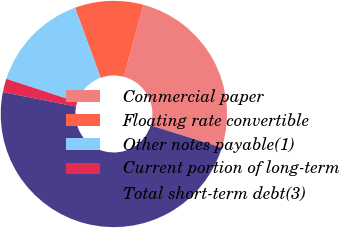Convert chart to OTSL. <chart><loc_0><loc_0><loc_500><loc_500><pie_chart><fcel>Commercial paper<fcel>Floating rate convertible<fcel>Other notes payable(1)<fcel>Current portion of long-term<fcel>Total short-term debt(3)<nl><fcel>25.61%<fcel>9.77%<fcel>14.4%<fcel>1.93%<fcel>48.29%<nl></chart> 